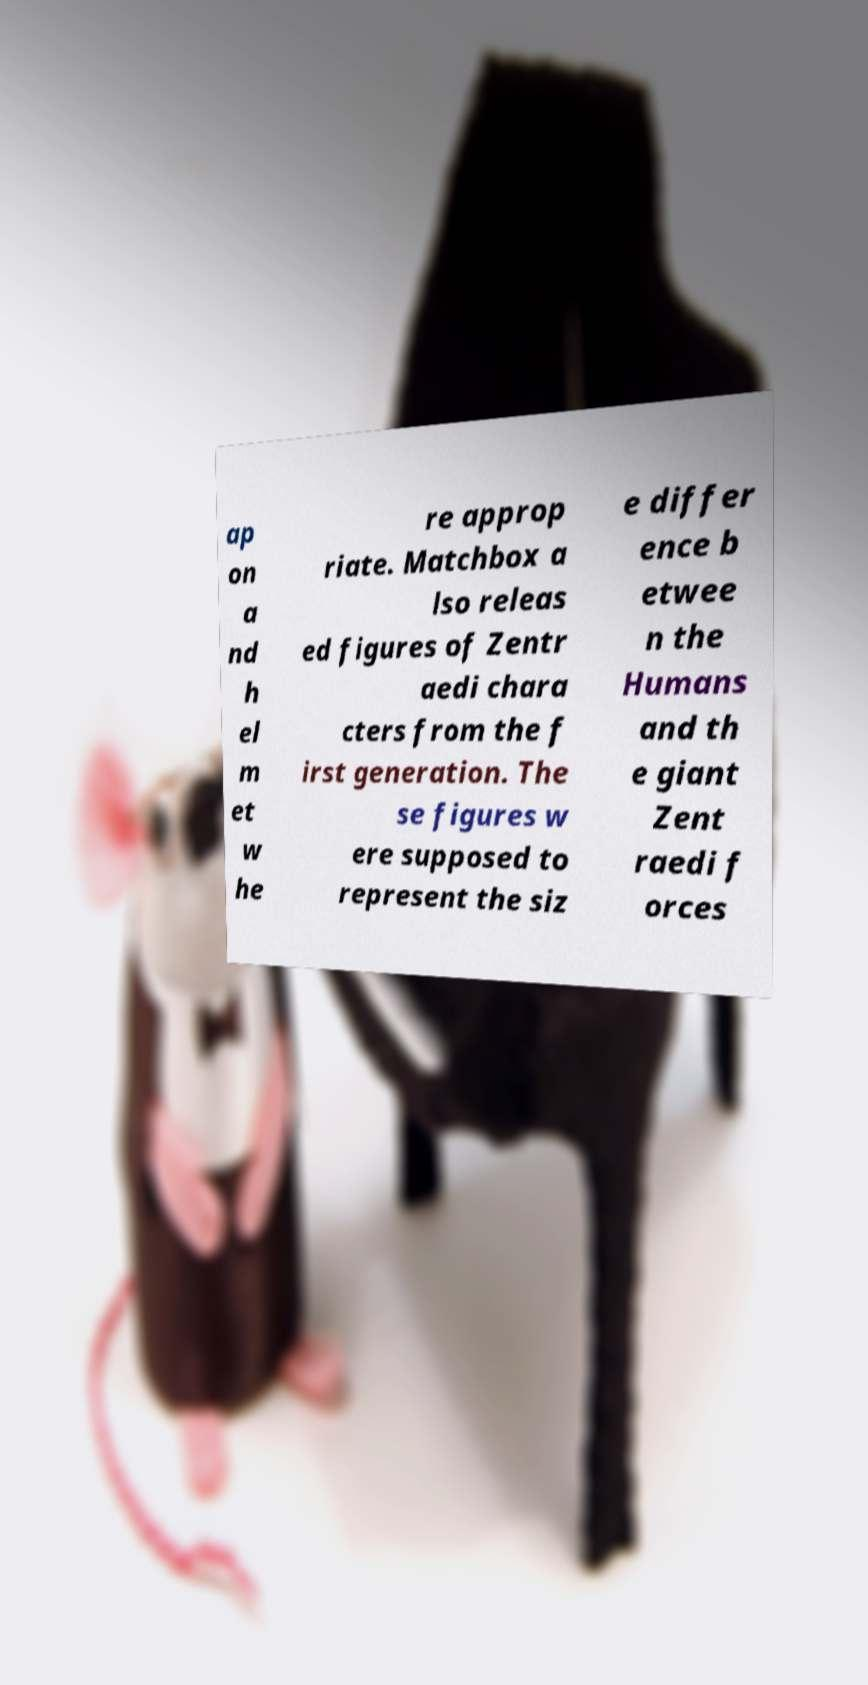What messages or text are displayed in this image? I need them in a readable, typed format. ap on a nd h el m et w he re approp riate. Matchbox a lso releas ed figures of Zentr aedi chara cters from the f irst generation. The se figures w ere supposed to represent the siz e differ ence b etwee n the Humans and th e giant Zent raedi f orces 